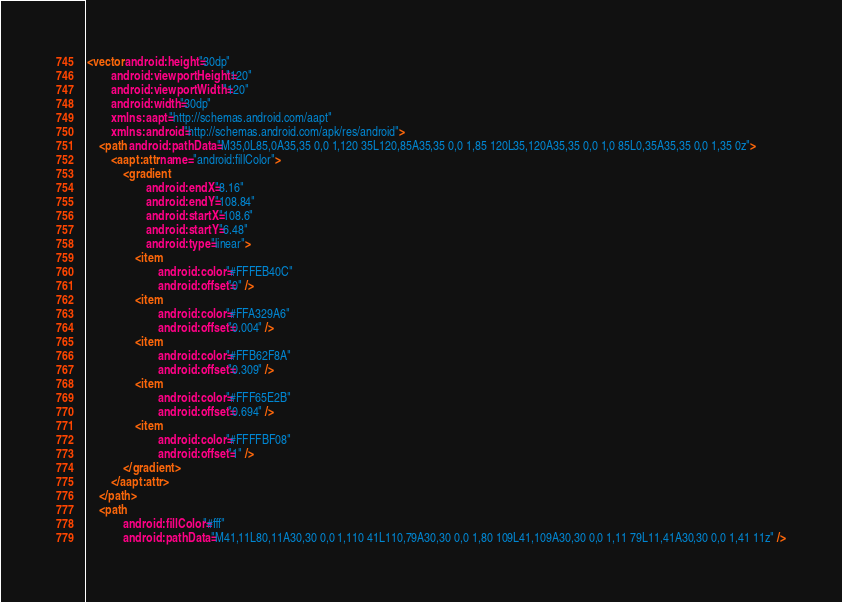<code> <loc_0><loc_0><loc_500><loc_500><_XML_><vector android:height="30dp"
        android:viewportHeight="120"
        android:viewportWidth="120"
        android:width="30dp"
        xmlns:aapt="http://schemas.android.com/aapt"
        xmlns:android="http://schemas.android.com/apk/res/android">
    <path android:pathData="M35,0L85,0A35,35 0,0 1,120 35L120,85A35,35 0,0 1,85 120L35,120A35,35 0,0 1,0 85L0,35A35,35 0,0 1,35 0z">
        <aapt:attr name="android:fillColor">
            <gradient
                    android:endX="8.16"
                    android:endY="108.84"
                    android:startX="108.6"
                    android:startY="6.48"
                    android:type="linear">
                <item
                        android:color="#FFFEB40C"
                        android:offset="0" />
                <item
                        android:color="#FFA329A6"
                        android:offset="0.004" />
                <item
                        android:color="#FFB62F8A"
                        android:offset="0.309" />
                <item
                        android:color="#FFF65E2B"
                        android:offset="0.694" />
                <item
                        android:color="#FFFFBF08"
                        android:offset="1" />
            </gradient>
        </aapt:attr>
    </path>
    <path
            android:fillColor="#fff"
            android:pathData="M41,11L80,11A30,30 0,0 1,110 41L110,79A30,30 0,0 1,80 109L41,109A30,30 0,0 1,11 79L11,41A30,30 0,0 1,41 11z" /></code> 